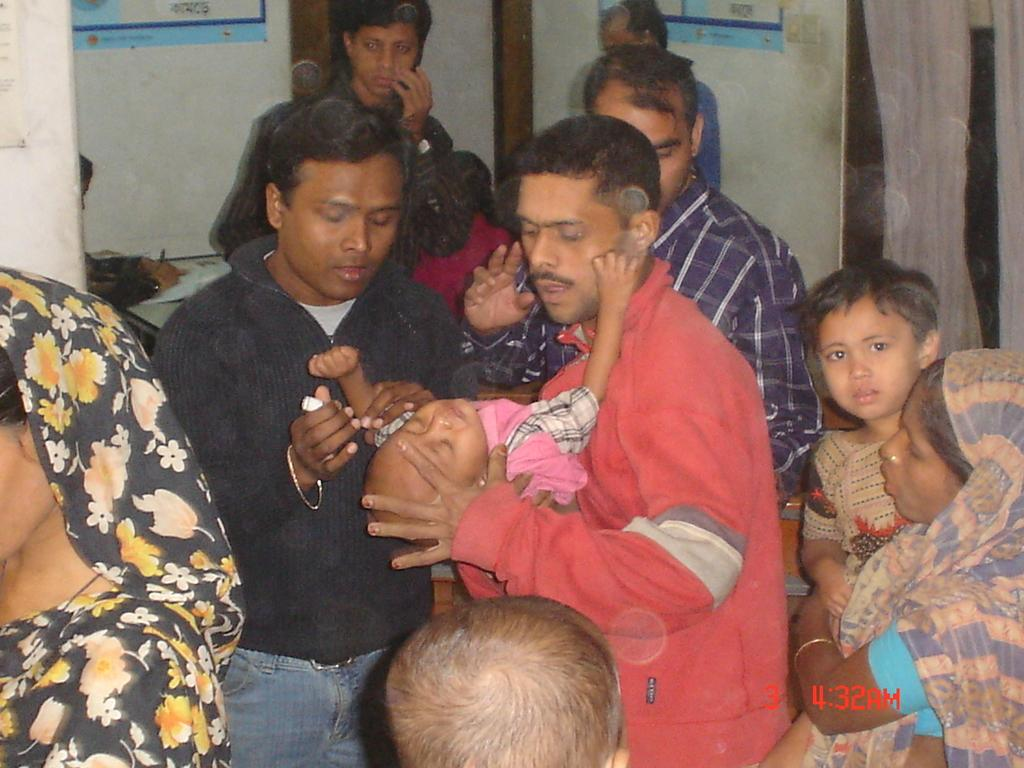How many people are in the room? There are people in the room, but the exact number is not specified. What is the man holding in the image? The man is holding a baby. What can be seen attached to the walls in the background? There are two posts attached to the walls in the background. How many pizzas are on the table in the image? There is no table or pizzas present in the image. Can you tell me the color of the toothbrush in the image? There is no toothbrush present in the image. 